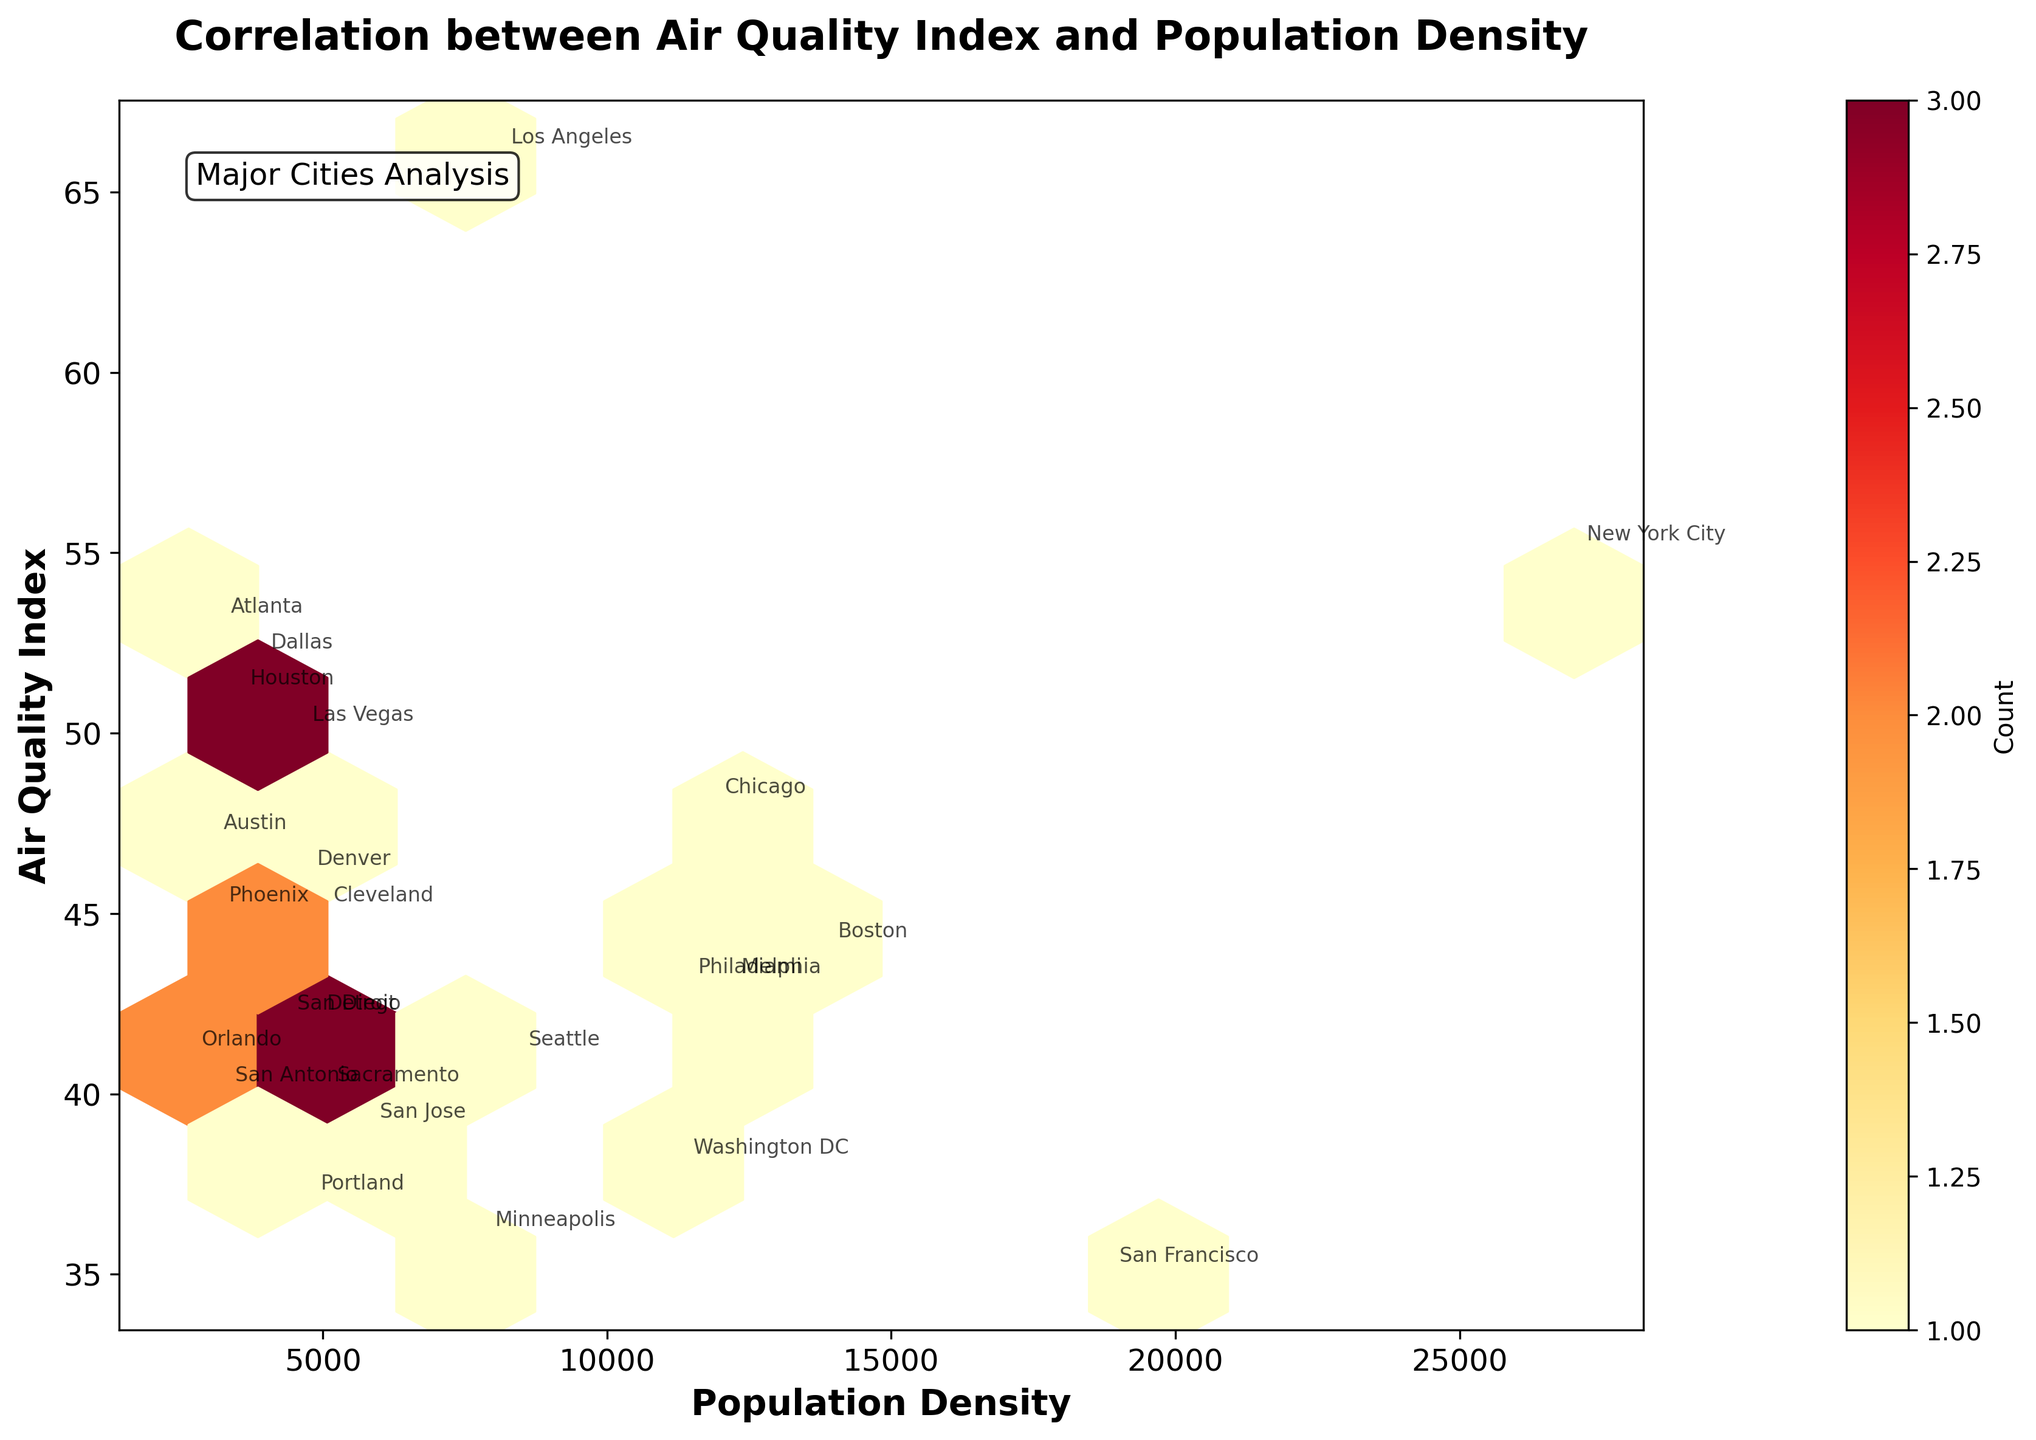What is the title of the plot? The title is located at the top of the figure, usually in a larger and bold font. It serves to provide a summary of the plot's content.
Answer: Correlation between Air Quality Index and Population Density How many cities are analyzed in this plot? Each city is represented by a hexbin in the plot, and the data points for each city are labeled with their names in smaller font just off the data points. By counting these labels, we can determine the number of cities.
Answer: 25 What is the range of Population Density displayed on the x-axis? The x-axis represents the Population Density. By looking at the lowest and highest values marked on this axis, we can determine the range displayed.
Answer: ~2500 to ~27500 Which city has the highest Air Quality Index, and what is that value? The Air Quality Index is plotted on the y-axis, and each city's data point is labeled. The highest y-value among these points, along with its corresponding label, indicates the city with the highest Air Quality Index.
Answer: Los Angeles, 66 Is there a general trend between Population Density and Air Quality Index? By observing the scatter and concentration of the hexagons on the plot, one can visually assess whether there is a trend such as an increase, decrease, or no clear pattern between the variables.
Answer: No clear pattern How many hexagons represent more than one city? The color coding on the hexbin plot (as indicated by the color bar) represents the count of cities. By identifying the hexagons that are not the lightest color, one can count how many represent multiple cities.
Answer: Six hexagons What is the Air Quality Index of San Francisco, and how does it compare to Washington DC? By locating both cities on the plot using their labels, we can directly read off their y-values (Air Quality Index) and compare them. San Francisco has an Air Quality Index of 35, Washington DC has 38.
Answer: San Francisco: 35, Washington DC: 38 Which city appears to have the lowest Population Density, and what is its Air Quality Index? Looking at the leftmost labeled data point on the x-axis (Population Density), one can identify the city and read its corresponding y-value (Air Quality Index).
Answer: Orlando, 41 How is the color bar used in this plot? The color bar on the right side of the plot provides a mapping of colors to the number of cities in each hexagon. By correlating the color of a hexagon to the color bar, one can determine the count.
Answer: Indicates hexagon counts Which cities lie within the hexagon with the highest count, and what are their Population Density and Air Quality Index values? By identifying the darkest hexagon (highest count) on the plot and then referencing the labeled cities it encompasses, we can list those cities along with their x and y values. Los Angeles (Population Density: 8092, Air Quality Index: 66), Seattle (Population Density: 8398, Air Quality Index: 41)
Answer: Los Angeles, Seattle 